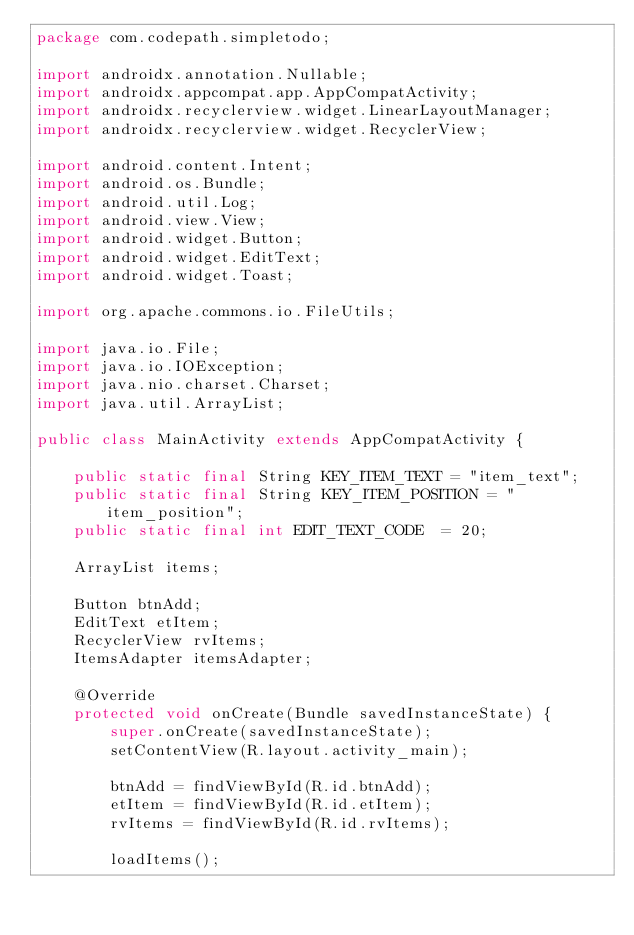Convert code to text. <code><loc_0><loc_0><loc_500><loc_500><_Java_>package com.codepath.simpletodo;

import androidx.annotation.Nullable;
import androidx.appcompat.app.AppCompatActivity;
import androidx.recyclerview.widget.LinearLayoutManager;
import androidx.recyclerview.widget.RecyclerView;

import android.content.Intent;
import android.os.Bundle;
import android.util.Log;
import android.view.View;
import android.widget.Button;
import android.widget.EditText;
import android.widget.Toast;

import org.apache.commons.io.FileUtils;

import java.io.File;
import java.io.IOException;
import java.nio.charset.Charset;
import java.util.ArrayList;

public class MainActivity extends AppCompatActivity {

    public static final String KEY_ITEM_TEXT = "item_text";
    public static final String KEY_ITEM_POSITION = "item_position";
    public static final int EDIT_TEXT_CODE  = 20;

    ArrayList items;

    Button btnAdd;
    EditText etItem;
    RecyclerView rvItems;
    ItemsAdapter itemsAdapter;

    @Override
    protected void onCreate(Bundle savedInstanceState) {
        super.onCreate(savedInstanceState);
        setContentView(R.layout.activity_main);

        btnAdd = findViewById(R.id.btnAdd);
        etItem = findViewById(R.id.etItem);
        rvItems = findViewById(R.id.rvItems);

        loadItems();
</code> 